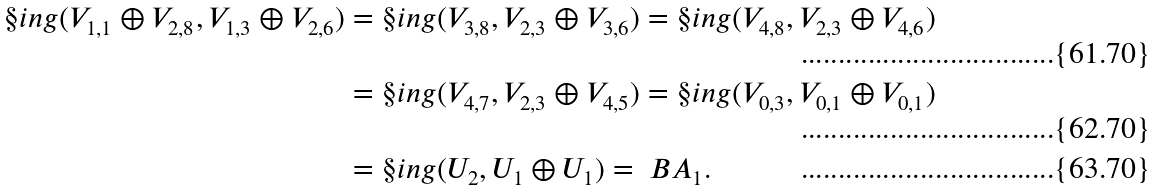Convert formula to latex. <formula><loc_0><loc_0><loc_500><loc_500>\S i n g ( V _ { 1 , 1 } \oplus V _ { 2 , 8 } , V _ { 1 , 3 } \oplus V _ { 2 , 6 } ) & = \S i n g ( V _ { 3 , 8 } , V _ { 2 , 3 } \oplus V _ { 3 , 6 } ) = \S i n g ( V _ { 4 , 8 } , V _ { 2 , 3 } \oplus V _ { 4 , 6 } ) \\ & = \S i n g ( V _ { 4 , 7 } , V _ { 2 , 3 } \oplus V _ { 4 , 5 } ) = \S i n g ( V _ { 0 , 3 } , V _ { 0 , 1 } \oplus V _ { 0 , 1 } ) \\ & = \S i n g ( U _ { 2 } , U _ { 1 } \oplus U _ { 1 } ) = \ B A _ { 1 } .</formula> 